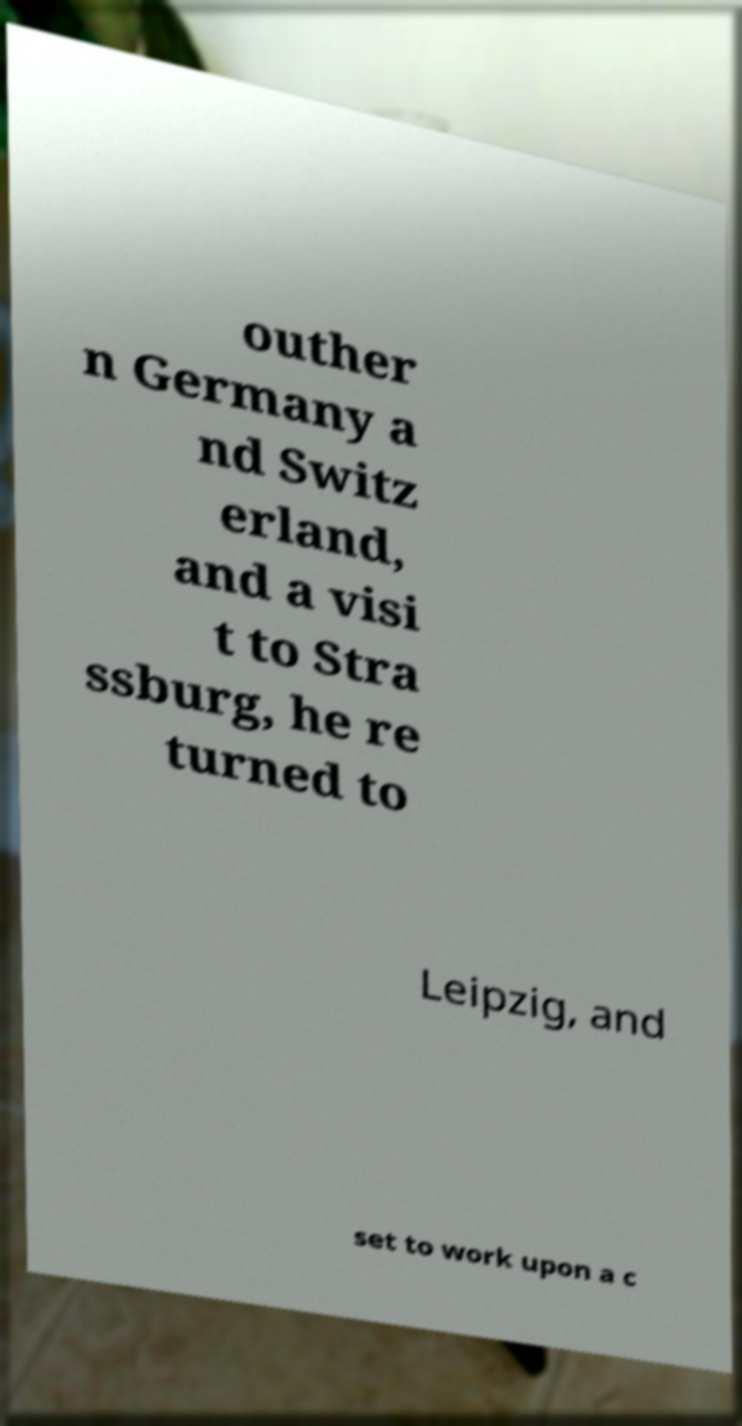Please identify and transcribe the text found in this image. outher n Germany a nd Switz erland, and a visi t to Stra ssburg, he re turned to Leipzig, and set to work upon a c 